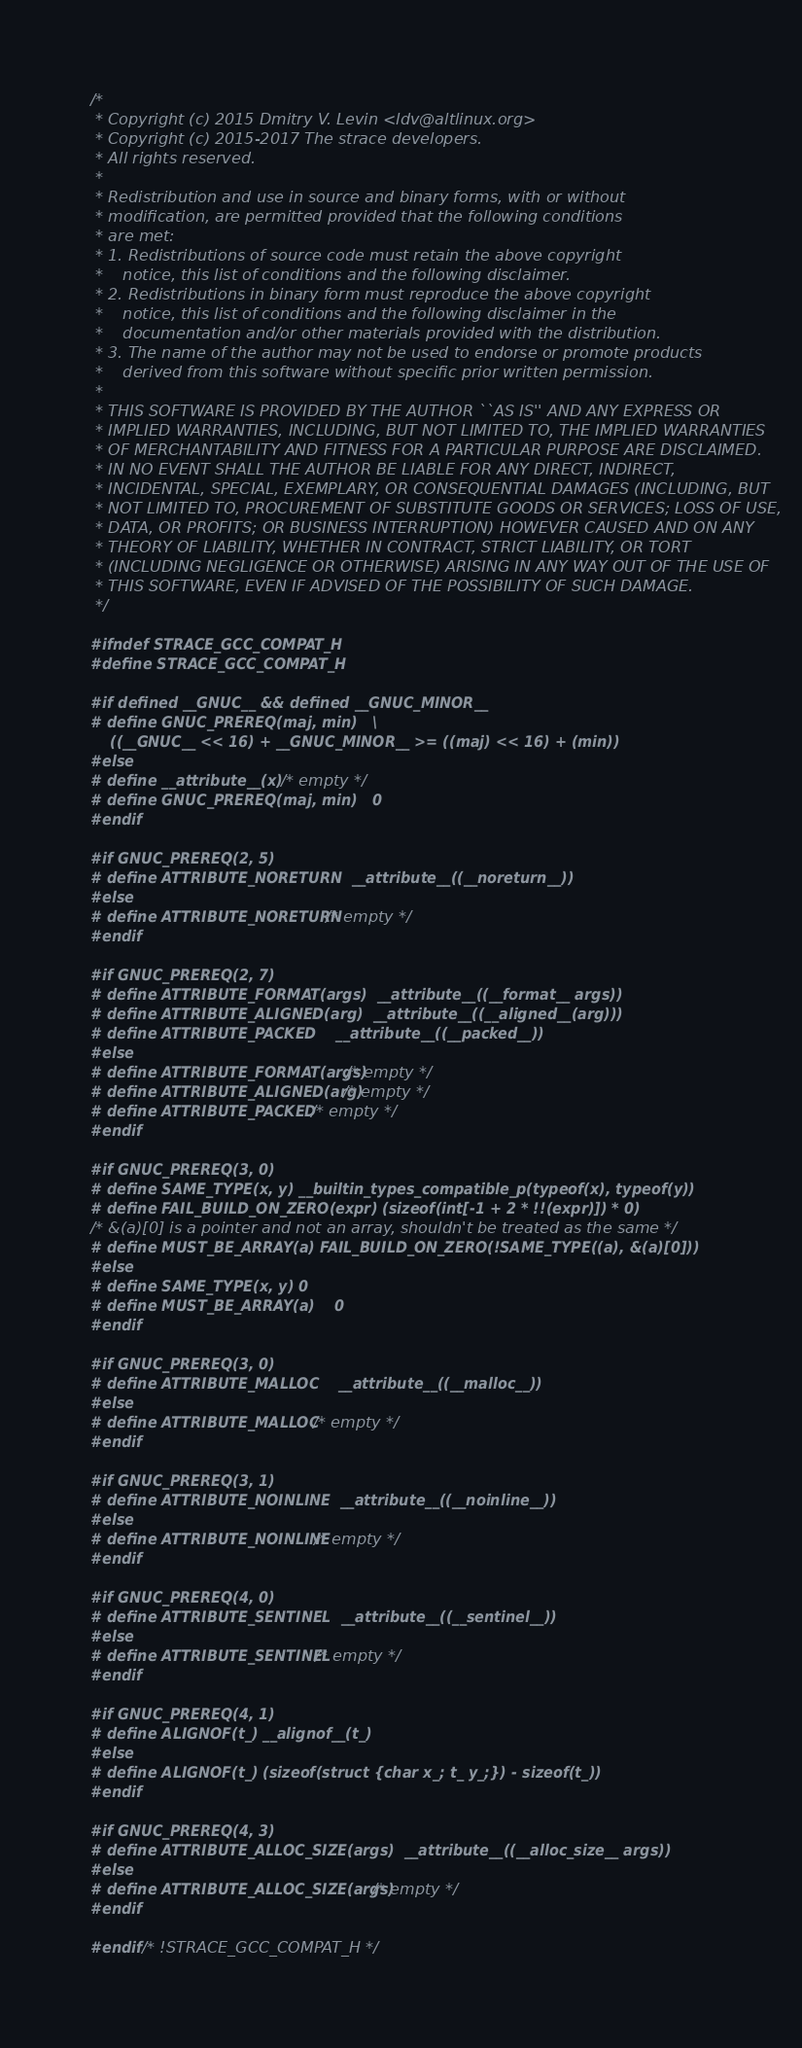<code> <loc_0><loc_0><loc_500><loc_500><_C_>/*
 * Copyright (c) 2015 Dmitry V. Levin <ldv@altlinux.org>
 * Copyright (c) 2015-2017 The strace developers.
 * All rights reserved.
 *
 * Redistribution and use in source and binary forms, with or without
 * modification, are permitted provided that the following conditions
 * are met:
 * 1. Redistributions of source code must retain the above copyright
 *    notice, this list of conditions and the following disclaimer.
 * 2. Redistributions in binary form must reproduce the above copyright
 *    notice, this list of conditions and the following disclaimer in the
 *    documentation and/or other materials provided with the distribution.
 * 3. The name of the author may not be used to endorse or promote products
 *    derived from this software without specific prior written permission.
 *
 * THIS SOFTWARE IS PROVIDED BY THE AUTHOR ``AS IS'' AND ANY EXPRESS OR
 * IMPLIED WARRANTIES, INCLUDING, BUT NOT LIMITED TO, THE IMPLIED WARRANTIES
 * OF MERCHANTABILITY AND FITNESS FOR A PARTICULAR PURPOSE ARE DISCLAIMED.
 * IN NO EVENT SHALL THE AUTHOR BE LIABLE FOR ANY DIRECT, INDIRECT,
 * INCIDENTAL, SPECIAL, EXEMPLARY, OR CONSEQUENTIAL DAMAGES (INCLUDING, BUT
 * NOT LIMITED TO, PROCUREMENT OF SUBSTITUTE GOODS OR SERVICES; LOSS OF USE,
 * DATA, OR PROFITS; OR BUSINESS INTERRUPTION) HOWEVER CAUSED AND ON ANY
 * THEORY OF LIABILITY, WHETHER IN CONTRACT, STRICT LIABILITY, OR TORT
 * (INCLUDING NEGLIGENCE OR OTHERWISE) ARISING IN ANY WAY OUT OF THE USE OF
 * THIS SOFTWARE, EVEN IF ADVISED OF THE POSSIBILITY OF SUCH DAMAGE.
 */

#ifndef STRACE_GCC_COMPAT_H
#define STRACE_GCC_COMPAT_H

#if defined __GNUC__ && defined __GNUC_MINOR__
# define GNUC_PREREQ(maj, min)	\
	((__GNUC__ << 16) + __GNUC_MINOR__ >= ((maj) << 16) + (min))
#else
# define __attribute__(x)	/* empty */
# define GNUC_PREREQ(maj, min)	0
#endif

#if GNUC_PREREQ(2, 5)
# define ATTRIBUTE_NORETURN	__attribute__((__noreturn__))
#else
# define ATTRIBUTE_NORETURN	/* empty */
#endif

#if GNUC_PREREQ(2, 7)
# define ATTRIBUTE_FORMAT(args)	__attribute__((__format__ args))
# define ATTRIBUTE_ALIGNED(arg)	__attribute__((__aligned__(arg)))
# define ATTRIBUTE_PACKED	__attribute__((__packed__))
#else
# define ATTRIBUTE_FORMAT(args)	/* empty */
# define ATTRIBUTE_ALIGNED(arg)	/* empty */
# define ATTRIBUTE_PACKED	/* empty */
#endif

#if GNUC_PREREQ(3, 0)
# define SAME_TYPE(x, y)	__builtin_types_compatible_p(typeof(x), typeof(y))
# define FAIL_BUILD_ON_ZERO(expr) (sizeof(int[-1 + 2 * !!(expr)]) * 0)
/* &(a)[0] is a pointer and not an array, shouldn't be treated as the same */
# define MUST_BE_ARRAY(a) FAIL_BUILD_ON_ZERO(!SAME_TYPE((a), &(a)[0]))
#else
# define SAME_TYPE(x, y)	0
# define MUST_BE_ARRAY(a)	0
#endif

#if GNUC_PREREQ(3, 0)
# define ATTRIBUTE_MALLOC	__attribute__((__malloc__))
#else
# define ATTRIBUTE_MALLOC	/* empty */
#endif

#if GNUC_PREREQ(3, 1)
# define ATTRIBUTE_NOINLINE	__attribute__((__noinline__))
#else
# define ATTRIBUTE_NOINLINE	/* empty */
#endif

#if GNUC_PREREQ(4, 0)
# define ATTRIBUTE_SENTINEL	__attribute__((__sentinel__))
#else
# define ATTRIBUTE_SENTINEL	/* empty */
#endif

#if GNUC_PREREQ(4, 1)
# define ALIGNOF(t_)	__alignof__(t_)
#else
# define ALIGNOF(t_)	(sizeof(struct {char x_; t_ y_;}) - sizeof(t_))
#endif

#if GNUC_PREREQ(4, 3)
# define ATTRIBUTE_ALLOC_SIZE(args)	__attribute__((__alloc_size__ args))
#else
# define ATTRIBUTE_ALLOC_SIZE(args)	/* empty */
#endif

#endif /* !STRACE_GCC_COMPAT_H */
</code> 